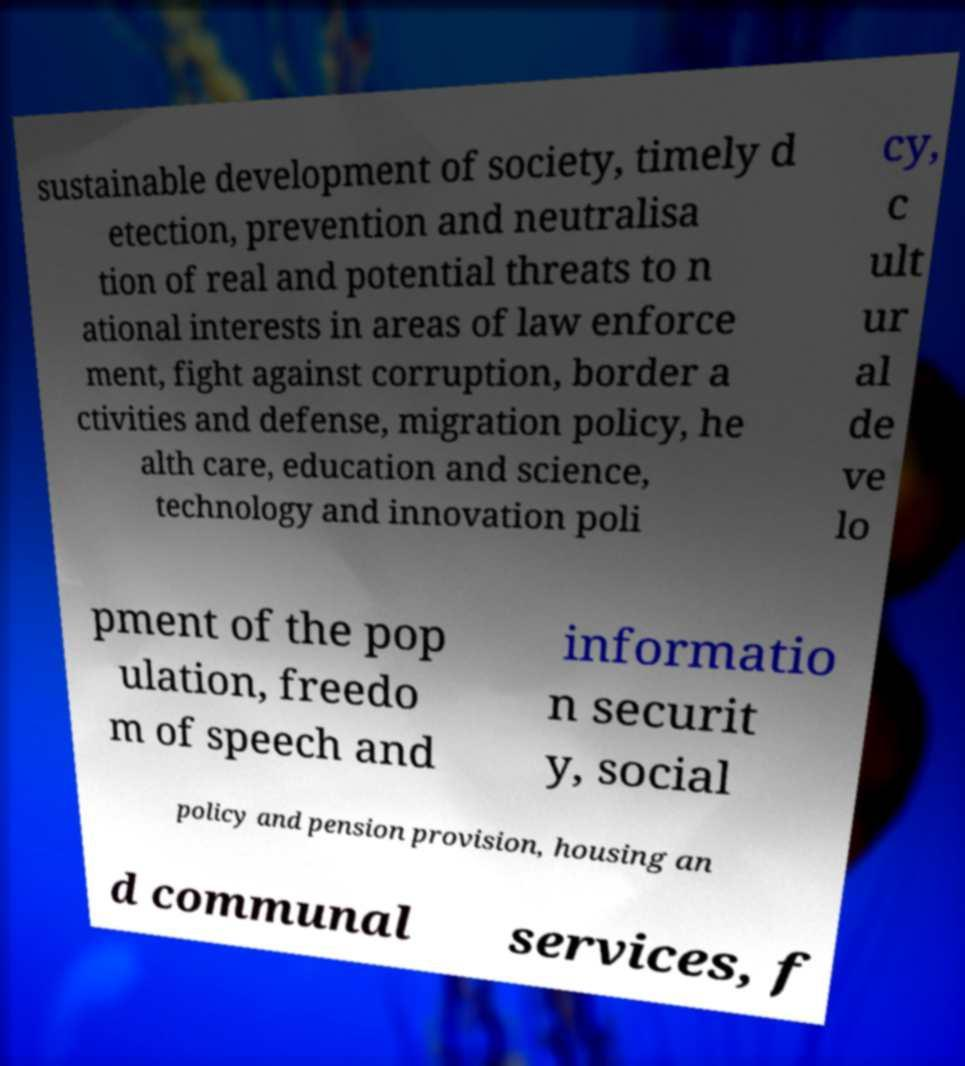There's text embedded in this image that I need extracted. Can you transcribe it verbatim? sustainable development of society, timely d etection, prevention and neutralisa tion of real and potential threats to n ational interests in areas of law enforce ment, fight against corruption, border a ctivities and defense, migration policy, he alth care, education and science, technology and innovation poli cy, c ult ur al de ve lo pment of the pop ulation, freedo m of speech and informatio n securit y, social policy and pension provision, housing an d communal services, f 